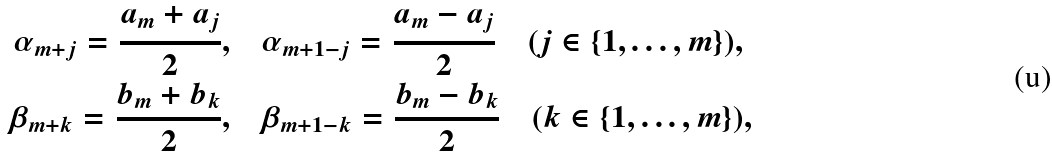Convert formula to latex. <formula><loc_0><loc_0><loc_500><loc_500>\alpha _ { m + j } = \frac { a _ { m } + a _ { j } } 2 , & \quad \alpha _ { m + 1 - j } = \frac { a _ { m } - a _ { j } } 2 \quad ( j \in \{ 1 , \dots , m \} ) , \\ \beta _ { m + k } = \frac { b _ { m } + b _ { k } } 2 , & \quad \beta _ { m + 1 - k } = \frac { b _ { m } - b _ { k } } 2 \quad ( k \in \{ 1 , \dots , m \} ) ,</formula> 